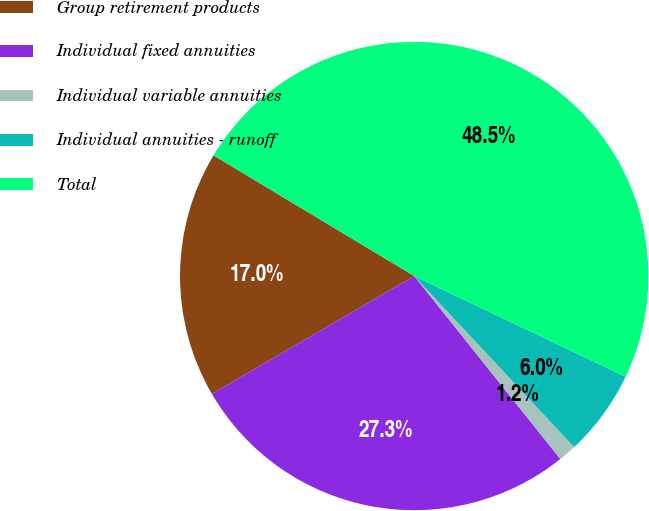<chart> <loc_0><loc_0><loc_500><loc_500><pie_chart><fcel>Group retirement products<fcel>Individual fixed annuities<fcel>Individual variable annuities<fcel>Individual annuities - runoff<fcel>Total<nl><fcel>17.01%<fcel>27.33%<fcel>1.24%<fcel>5.96%<fcel>48.46%<nl></chart> 